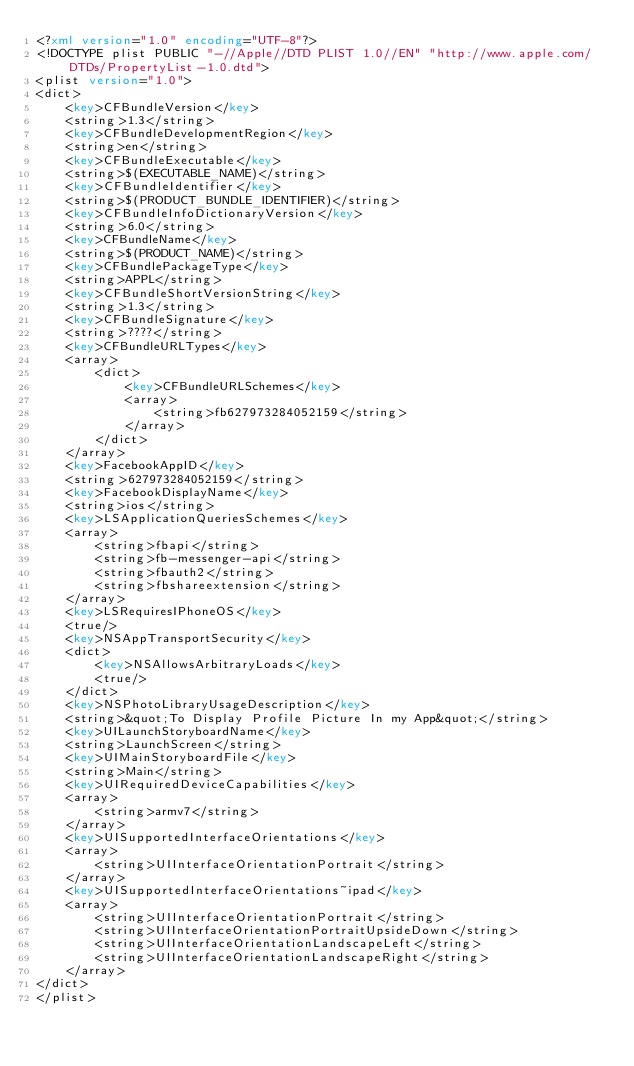<code> <loc_0><loc_0><loc_500><loc_500><_XML_><?xml version="1.0" encoding="UTF-8"?>
<!DOCTYPE plist PUBLIC "-//Apple//DTD PLIST 1.0//EN" "http://www.apple.com/DTDs/PropertyList-1.0.dtd">
<plist version="1.0">
<dict>
	<key>CFBundleVersion</key>
	<string>1.3</string>
	<key>CFBundleDevelopmentRegion</key>
	<string>en</string>
	<key>CFBundleExecutable</key>
	<string>$(EXECUTABLE_NAME)</string>
	<key>CFBundleIdentifier</key>
	<string>$(PRODUCT_BUNDLE_IDENTIFIER)</string>
	<key>CFBundleInfoDictionaryVersion</key>
	<string>6.0</string>
	<key>CFBundleName</key>
	<string>$(PRODUCT_NAME)</string>
	<key>CFBundlePackageType</key>
	<string>APPL</string>
	<key>CFBundleShortVersionString</key>
	<string>1.3</string>
	<key>CFBundleSignature</key>
	<string>????</string>
	<key>CFBundleURLTypes</key>
	<array>
		<dict>
			<key>CFBundleURLSchemes</key>
			<array>
				<string>fb627973284052159</string>
			</array>
		</dict>
	</array>
	<key>FacebookAppID</key>
	<string>627973284052159</string>
	<key>FacebookDisplayName</key>
	<string>ios</string>
	<key>LSApplicationQueriesSchemes</key>
	<array>
		<string>fbapi</string>
		<string>fb-messenger-api</string>
		<string>fbauth2</string>
		<string>fbshareextension</string>
	</array>
	<key>LSRequiresIPhoneOS</key>
	<true/>
	<key>NSAppTransportSecurity</key>
	<dict>
		<key>NSAllowsArbitraryLoads</key>
		<true/>
	</dict>
	<key>NSPhotoLibraryUsageDescription</key>
	<string>&quot;To Display Profile Picture In my App&quot;</string>
	<key>UILaunchStoryboardName</key>
	<string>LaunchScreen</string>
	<key>UIMainStoryboardFile</key>
	<string>Main</string>
	<key>UIRequiredDeviceCapabilities</key>
	<array>
		<string>armv7</string>
	</array>
	<key>UISupportedInterfaceOrientations</key>
	<array>
		<string>UIInterfaceOrientationPortrait</string>
	</array>
	<key>UISupportedInterfaceOrientations~ipad</key>
	<array>
		<string>UIInterfaceOrientationPortrait</string>
		<string>UIInterfaceOrientationPortraitUpsideDown</string>
		<string>UIInterfaceOrientationLandscapeLeft</string>
		<string>UIInterfaceOrientationLandscapeRight</string>
	</array>
</dict>
</plist>
</code> 